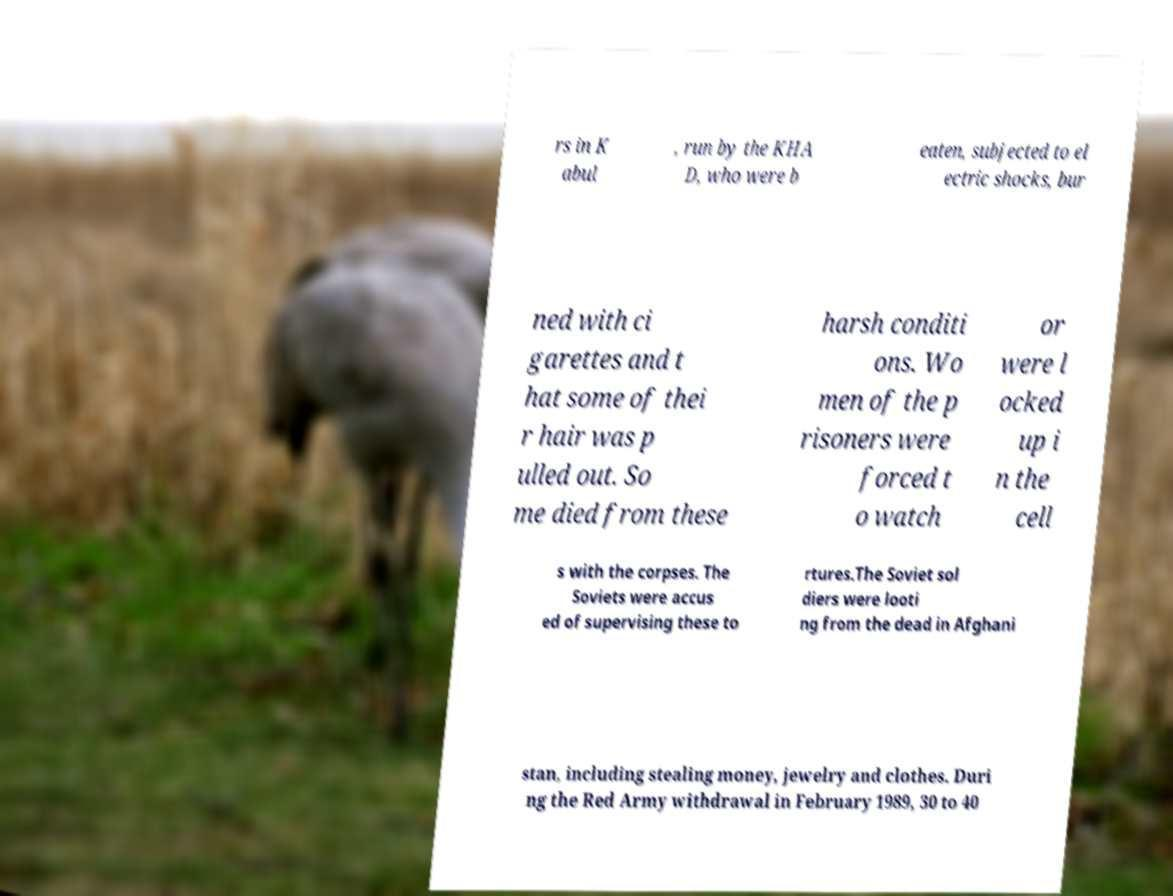There's text embedded in this image that I need extracted. Can you transcribe it verbatim? rs in K abul , run by the KHA D, who were b eaten, subjected to el ectric shocks, bur ned with ci garettes and t hat some of thei r hair was p ulled out. So me died from these harsh conditi ons. Wo men of the p risoners were forced t o watch or were l ocked up i n the cell s with the corpses. The Soviets were accus ed of supervising these to rtures.The Soviet sol diers were looti ng from the dead in Afghani stan, including stealing money, jewelry and clothes. Duri ng the Red Army withdrawal in February 1989, 30 to 40 